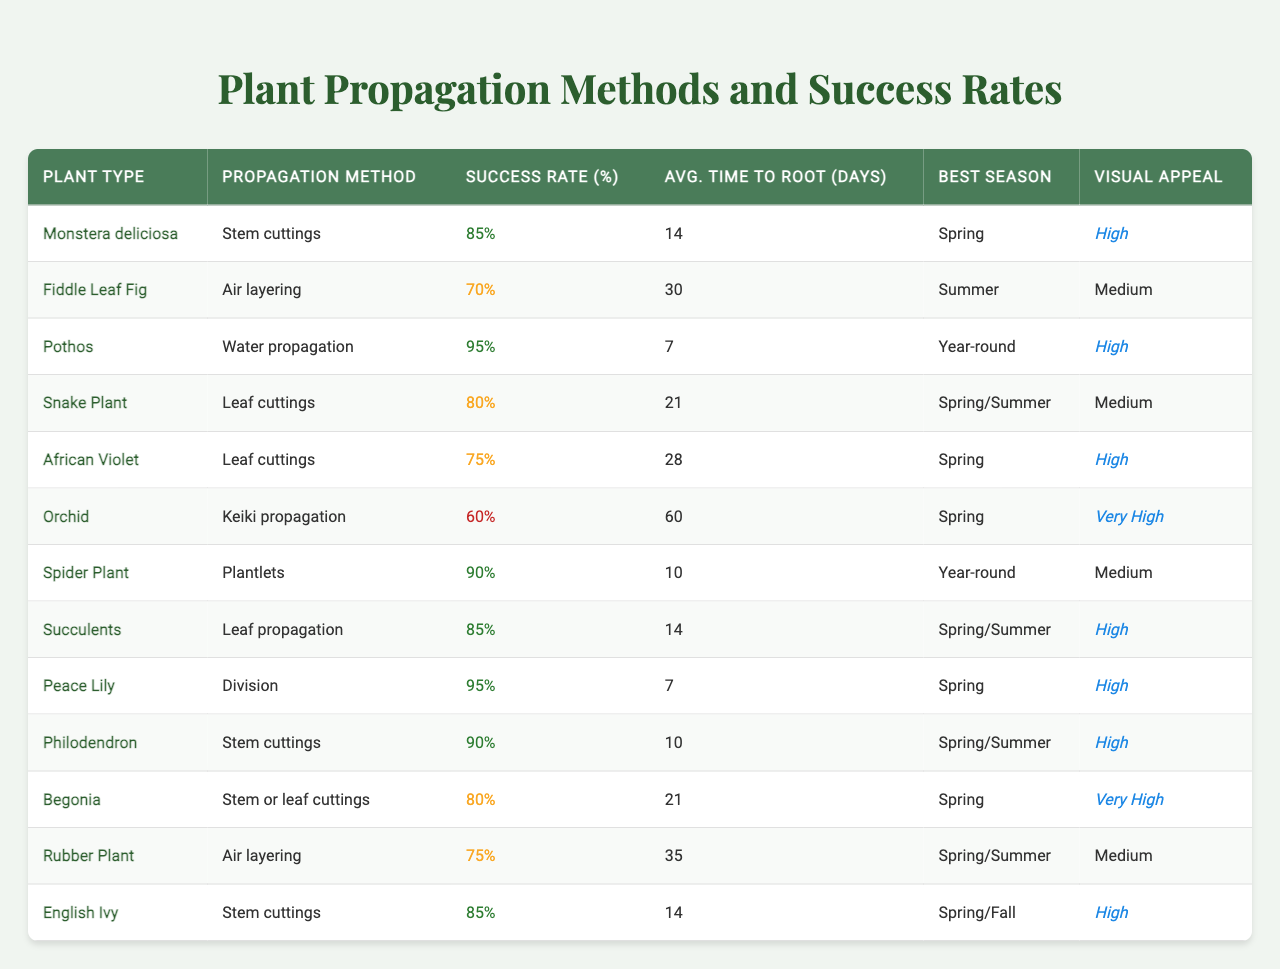What is the success rate of Pothos propagation? The table lists the success rate for Pothos under the "Success Rate (%)" column, which is 95%.
Answer: 95% Which plant has the highest success rate for propagation? By reviewing the "Success Rate (%)" column, Pothos has the highest success rate at 95%.
Answer: Pothos How long does it typically take for Snake Plant cuttings to root? The average time for Snake Plant to root is found in the "Avg. Time to Root (days)" column, which states 21 days.
Answer: 21 days Is the Fiddle Leaf Fig's propagation method effective during Spring? The table indicates that Fiddle Leaf Fig uses air layering, and it is best propagated in Summer, meaning it's not effective in Spring.
Answer: No What are the common propagation methods for plants with a success rate above 80%? The plants with a success rate above 80% are Pothos (water propagation), Peace Lily (division), Philodendron (stem cuttings), Monstera deliciosa (stem cuttings), Snake Plant (leaf cuttings), Spider Plant (plantlets), and Succulents (leaf propagation).
Answer: 7 Which propagation method has the fastest average rooting time? Looking at the "Avg. Time to Root (days)" column, Water propagation for Pothos and Peace Lily's division both take 7 days, making it the fastest.
Answer: 7 days What is the overall average success rate for propagation methods in the table? The total success rates for the plants are (85 + 70 + 95 + 80 + 75 + 60 + 90 + 85 + 95 + 90 + 80 + 75 + 85)/13 = 80.38%.
Answer: Approximately 80.38% Do any plants have a success rate of 60% or lower? Checking the "Success Rate (%)" column, only Orchid has a success rate of 60%, so yes, there is one.
Answer: Yes Which plant has a visual appeal rated as "Very High" and what is its propagation method? The plant rated "Very High" in visual appeal is Orchids, with a propagation method of keiki propagation.
Answer: Orchid; Keiki propagation If we consider only the plants with high visual appeal, which has the longest average rooting time? The plants with high visual appeal are Pothos, Spider Plant, Peace Lily, Philodendron, and Begonia. Their average rooting times are 7, 10, 7, 10, and 21 days respectively; Begonia has the longest time.
Answer: Begonia What is the primary propagation method for African Violet, and what is its success rate? African Violet is propagated using leaf cuttings, which has a success rate of 75%.
Answer: Leaf cuttings; 75% 